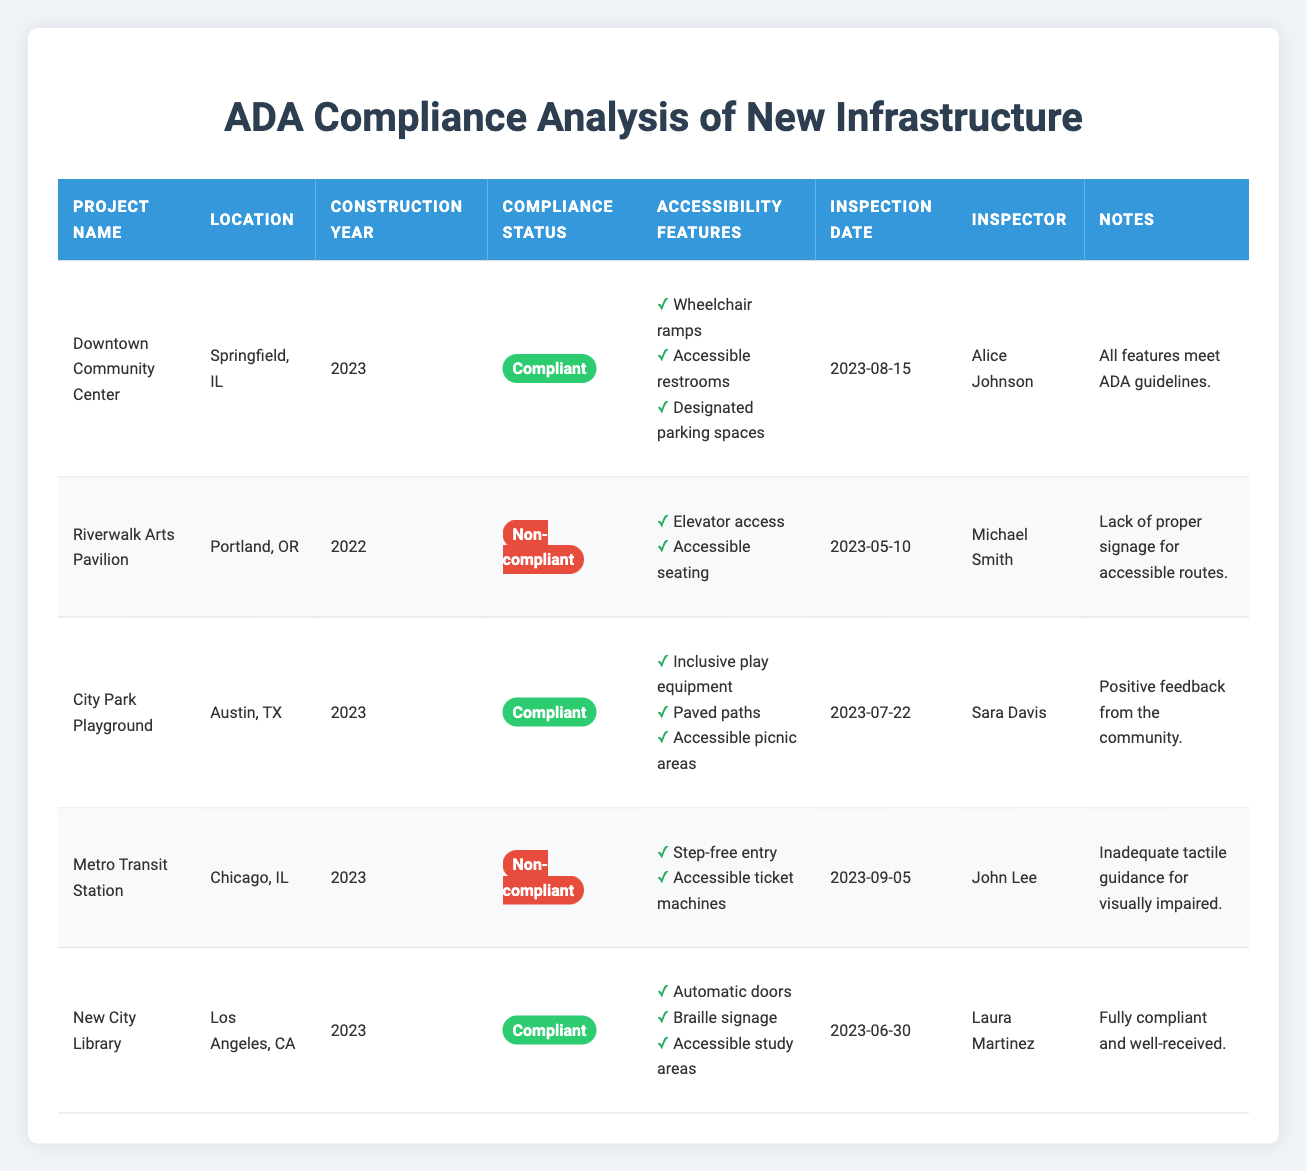What is the ADA compliance status of the Downtown Community Center? The table indicates that the Downtown Community Center has a compliance status of "Compliant" in the relevant column.
Answer: Compliant How many projects were constructed in 2023? By checking the "Construction Year" column, we see that the projects "Downtown Community Center," "City Park Playground," "Metro Transit Station," and "New City Library" were all constructed in 2023, totaling four projects.
Answer: 4 Which project had an inspection conducted by Michael Smith? According to the table, Michael Smith is listed as the inspector for the "Riverwalk Arts Pavilion."
Answer: Riverwalk Arts Pavilion Is the New City Library considered compliant with ADA standards? The table shows that the New City Library's ADA compliance status is "Compliant," indicating that it meets the necessary standards.
Answer: Yes What is the total number of compliant projects in the table? Upon reviewing the table, the projects "Downtown Community Center," "City Park Playground," and "New City Library" are compliant, totaling three compliant projects.
Answer: 3 What notable feature is missing from the Riverwalk Arts Pavilion? The table includes a note stating that the Riverwalk Arts Pavilion lacks proper signage for accessible routes, identifying it as a major deficiency.
Answer: Lack of proper signage for accessible routes Which location has the most recent inspection date? To determine the most recent inspection date, we compare the inspection dates: the "Metro Transit Station" on September 5, 2023, and others that are earlier. Therefore, it has the most recent date.
Answer: Chicago, IL (Metro Transit Station) Are all projects in Chicago compliant with ADA standards? The only project listed in Chicago is the "Metro Transit Station," which is marked as "Non-compliant," indicating that not all projects in Chicago meet standards.
Answer: No 